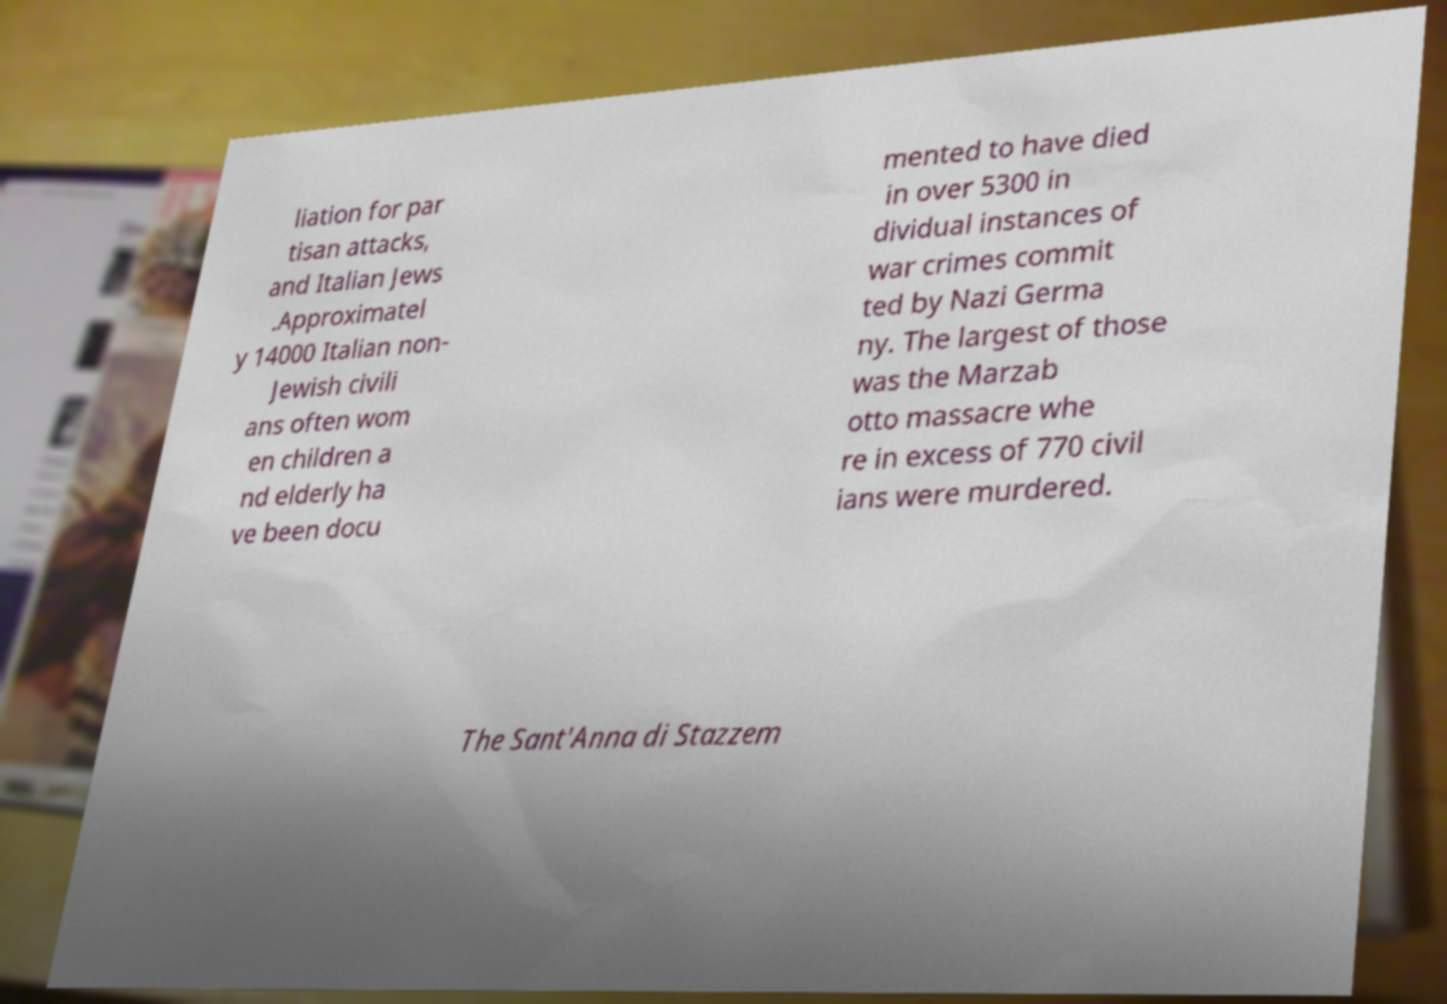Could you extract and type out the text from this image? liation for par tisan attacks, and Italian Jews .Approximatel y 14000 Italian non- Jewish civili ans often wom en children a nd elderly ha ve been docu mented to have died in over 5300 in dividual instances of war crimes commit ted by Nazi Germa ny. The largest of those was the Marzab otto massacre whe re in excess of 770 civil ians were murdered. The Sant'Anna di Stazzem 